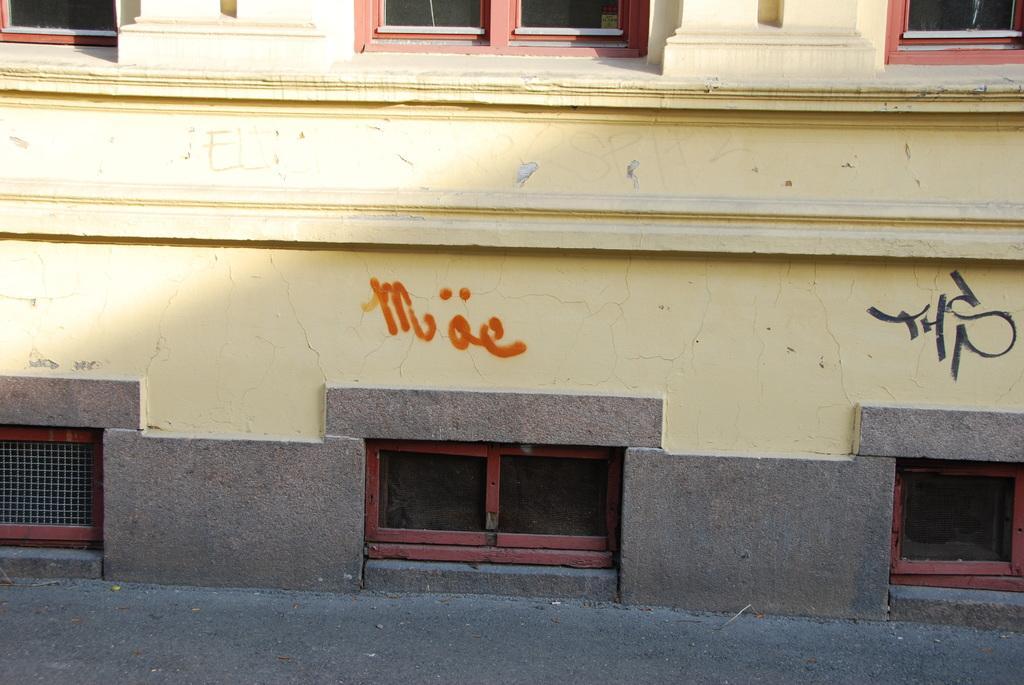How would you summarize this image in a sentence or two? In this image I can see the building in yellow color and I can also see few glass windows. 